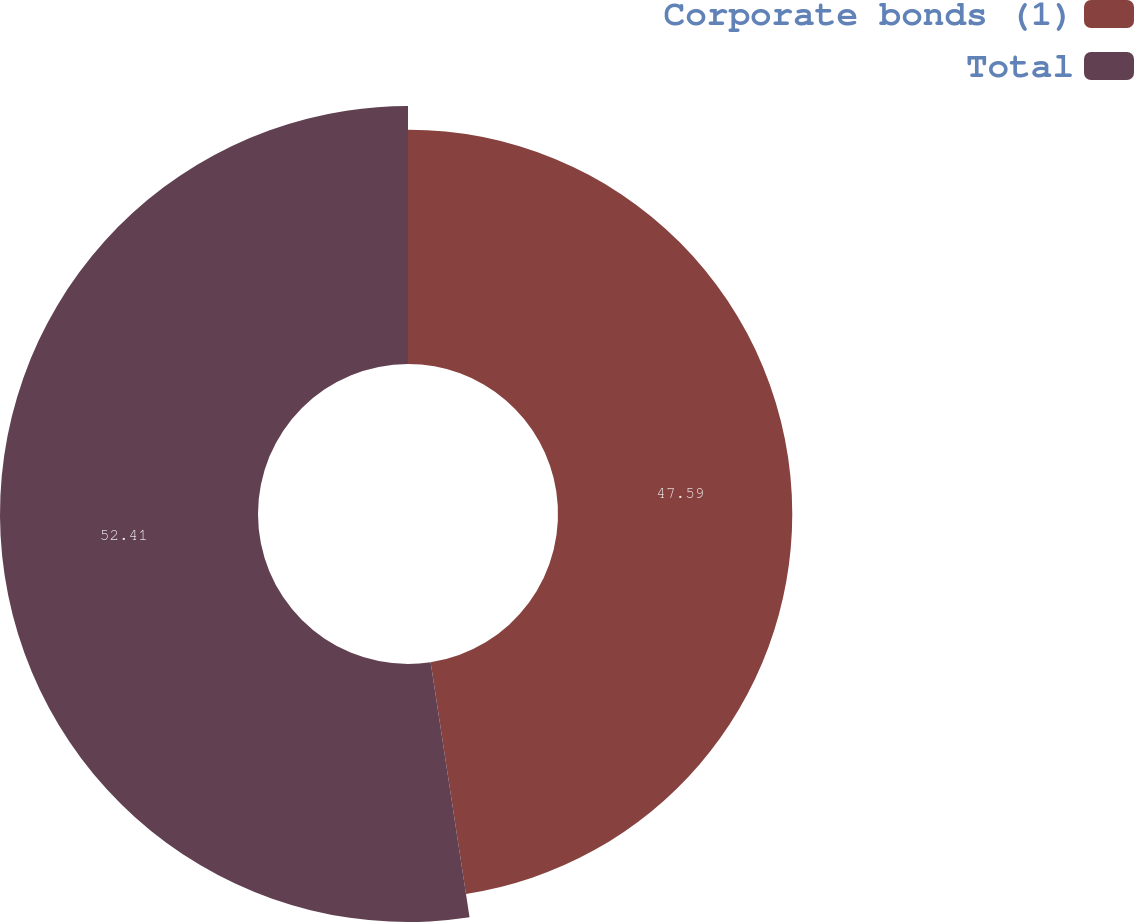Convert chart to OTSL. <chart><loc_0><loc_0><loc_500><loc_500><pie_chart><fcel>Corporate bonds (1)<fcel>Total<nl><fcel>47.59%<fcel>52.41%<nl></chart> 